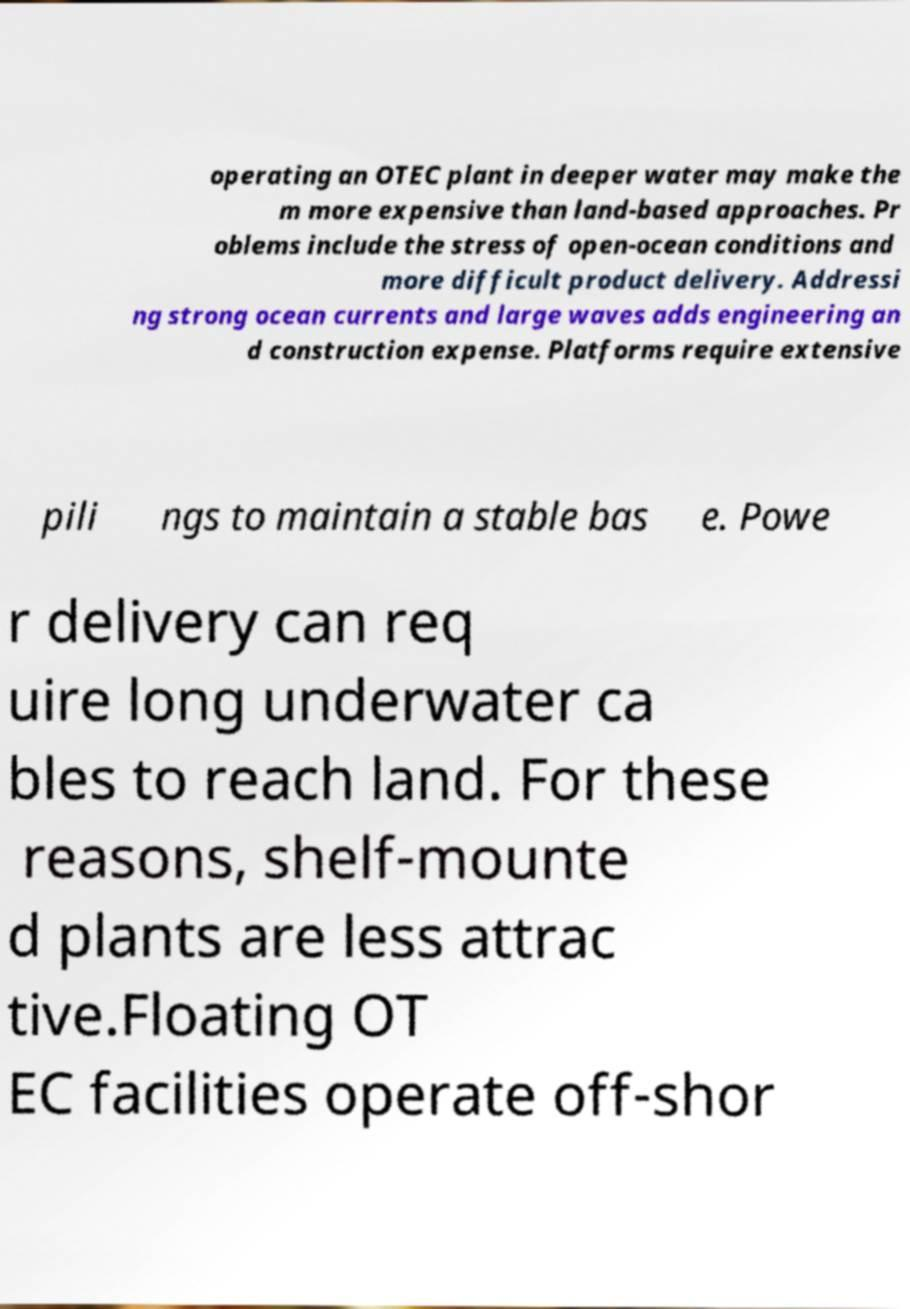Can you read and provide the text displayed in the image?This photo seems to have some interesting text. Can you extract and type it out for me? operating an OTEC plant in deeper water may make the m more expensive than land-based approaches. Pr oblems include the stress of open-ocean conditions and more difficult product delivery. Addressi ng strong ocean currents and large waves adds engineering an d construction expense. Platforms require extensive pili ngs to maintain a stable bas e. Powe r delivery can req uire long underwater ca bles to reach land. For these reasons, shelf-mounte d plants are less attrac tive.Floating OT EC facilities operate off-shor 